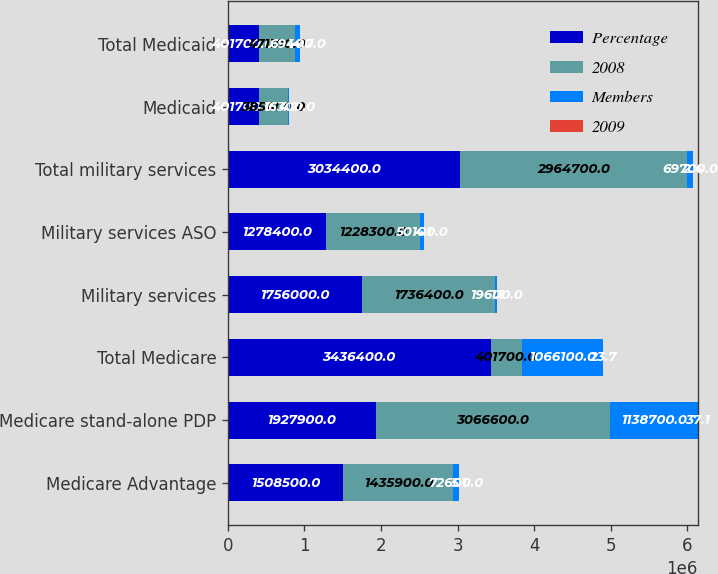<chart> <loc_0><loc_0><loc_500><loc_500><stacked_bar_chart><ecel><fcel>Medicare Advantage<fcel>Medicare stand-alone PDP<fcel>Total Medicare<fcel>Military services<fcel>Military services ASO<fcel>Total military services<fcel>Medicaid<fcel>Total Medicaid<nl><fcel>Percentage<fcel>1.5085e+06<fcel>1.9279e+06<fcel>3.4364e+06<fcel>1.756e+06<fcel>1.2784e+06<fcel>3.0344e+06<fcel>401700<fcel>401700<nl><fcel>2008<fcel>1.4359e+06<fcel>3.0666e+06<fcel>401700<fcel>1.7364e+06<fcel>1.2283e+06<fcel>2.9647e+06<fcel>385400<fcel>471100<nl><fcel>Members<fcel>72600<fcel>1.1387e+06<fcel>1.0661e+06<fcel>19600<fcel>50100<fcel>69700<fcel>16300<fcel>69400<nl><fcel>2009<fcel>5.1<fcel>37.1<fcel>23.7<fcel>1.1<fcel>4.1<fcel>2.4<fcel>4.2<fcel>14.7<nl></chart> 